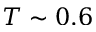Convert formula to latex. <formula><loc_0><loc_0><loc_500><loc_500>T \sim 0 . 6</formula> 